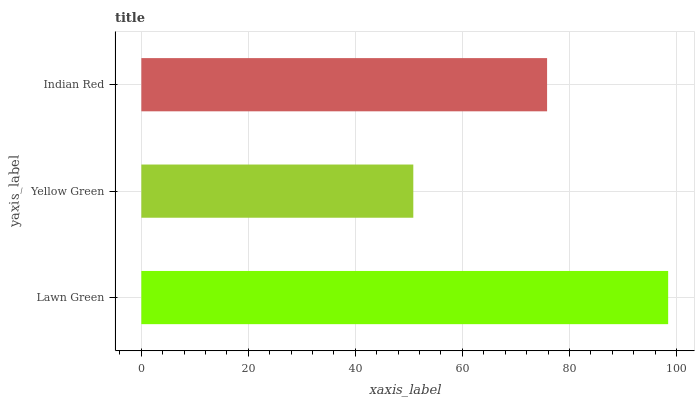Is Yellow Green the minimum?
Answer yes or no. Yes. Is Lawn Green the maximum?
Answer yes or no. Yes. Is Indian Red the minimum?
Answer yes or no. No. Is Indian Red the maximum?
Answer yes or no. No. Is Indian Red greater than Yellow Green?
Answer yes or no. Yes. Is Yellow Green less than Indian Red?
Answer yes or no. Yes. Is Yellow Green greater than Indian Red?
Answer yes or no. No. Is Indian Red less than Yellow Green?
Answer yes or no. No. Is Indian Red the high median?
Answer yes or no. Yes. Is Indian Red the low median?
Answer yes or no. Yes. Is Lawn Green the high median?
Answer yes or no. No. Is Lawn Green the low median?
Answer yes or no. No. 